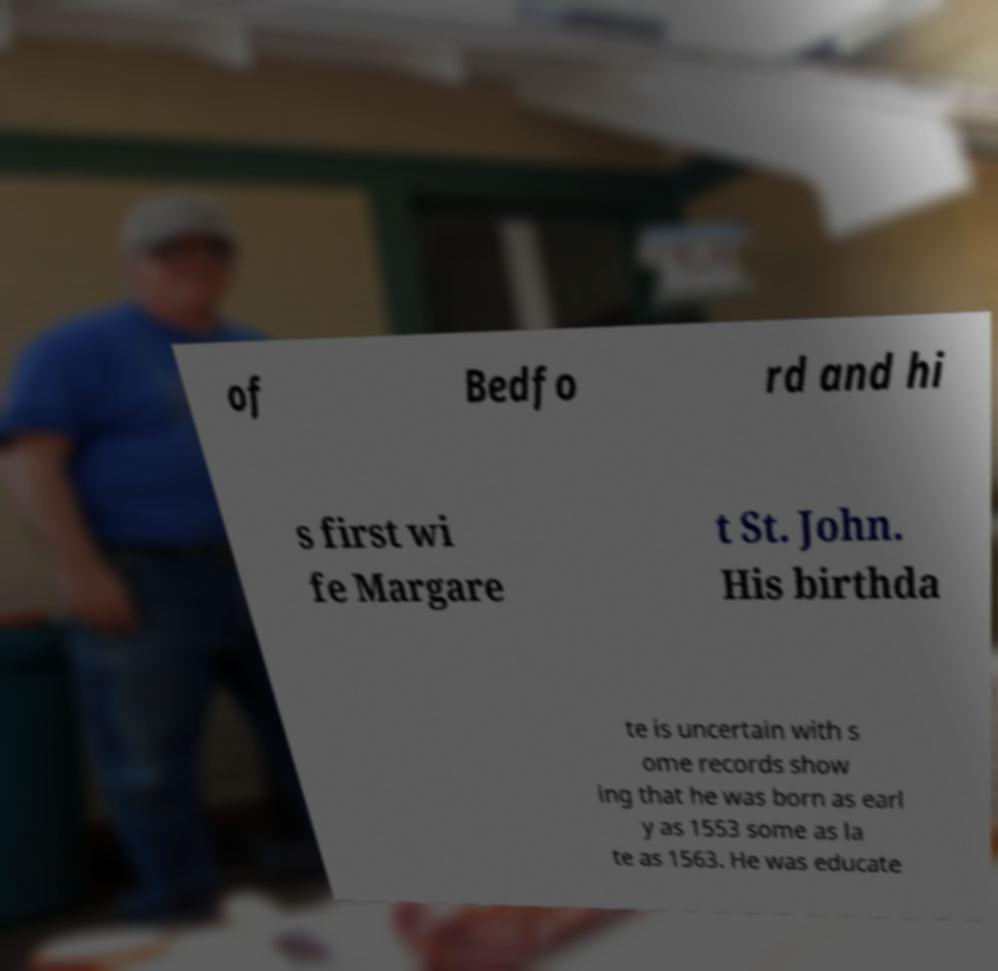For documentation purposes, I need the text within this image transcribed. Could you provide that? of Bedfo rd and hi s first wi fe Margare t St. John. His birthda te is uncertain with s ome records show ing that he was born as earl y as 1553 some as la te as 1563. He was educate 